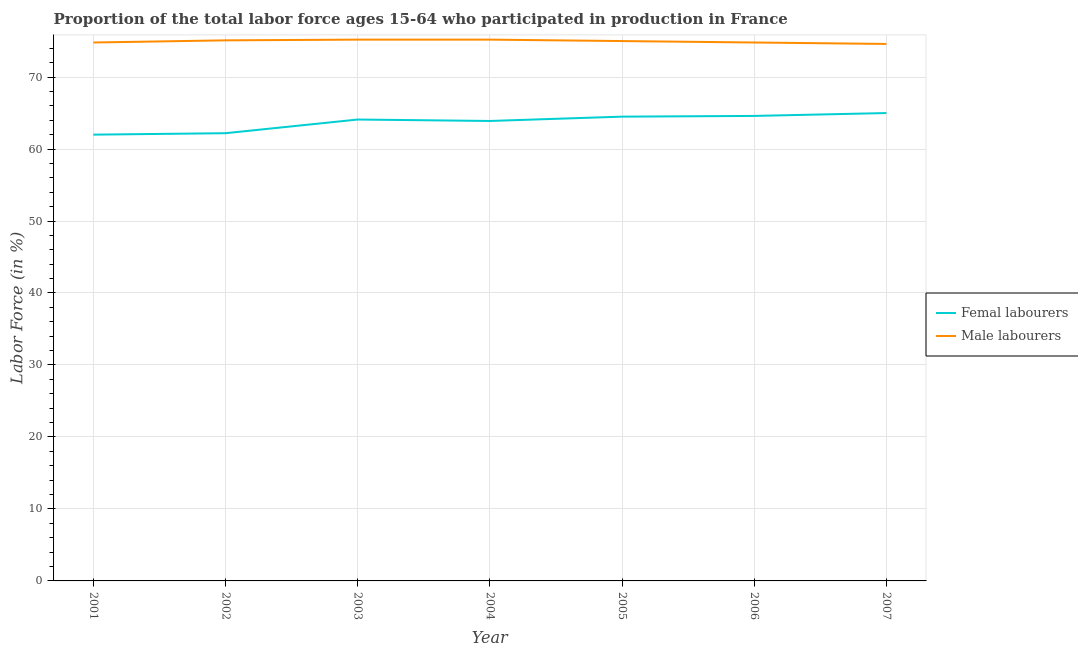Does the line corresponding to percentage of female labor force intersect with the line corresponding to percentage of male labour force?
Give a very brief answer. No. Is the number of lines equal to the number of legend labels?
Provide a short and direct response. Yes. What is the percentage of male labour force in 2006?
Keep it short and to the point. 74.8. Across all years, what is the maximum percentage of female labor force?
Provide a succinct answer. 65. Across all years, what is the minimum percentage of female labor force?
Offer a terse response. 62. In which year was the percentage of female labor force minimum?
Your response must be concise. 2001. What is the total percentage of male labour force in the graph?
Provide a succinct answer. 524.7. What is the difference between the percentage of male labour force in 2003 and that in 2005?
Offer a very short reply. 0.2. What is the difference between the percentage of male labour force in 2003 and the percentage of female labor force in 2001?
Give a very brief answer. 13.2. What is the average percentage of male labour force per year?
Offer a terse response. 74.96. In how many years, is the percentage of female labor force greater than 2 %?
Keep it short and to the point. 7. What is the ratio of the percentage of male labour force in 2001 to that in 2004?
Give a very brief answer. 0.99. Is the percentage of female labor force in 2004 less than that in 2005?
Give a very brief answer. Yes. Is the difference between the percentage of male labour force in 2004 and 2007 greater than the difference between the percentage of female labor force in 2004 and 2007?
Your response must be concise. Yes. What is the difference between the highest and the second highest percentage of male labour force?
Your answer should be very brief. 0. What is the difference between the highest and the lowest percentage of male labour force?
Offer a very short reply. 0.6. Is the sum of the percentage of male labour force in 2001 and 2007 greater than the maximum percentage of female labor force across all years?
Give a very brief answer. Yes. Is the percentage of female labor force strictly less than the percentage of male labour force over the years?
Give a very brief answer. Yes. How many lines are there?
Give a very brief answer. 2. Does the graph contain any zero values?
Make the answer very short. No. Where does the legend appear in the graph?
Your answer should be very brief. Center right. How many legend labels are there?
Ensure brevity in your answer.  2. What is the title of the graph?
Provide a short and direct response. Proportion of the total labor force ages 15-64 who participated in production in France. Does "Malaria" appear as one of the legend labels in the graph?
Provide a succinct answer. No. What is the label or title of the X-axis?
Give a very brief answer. Year. What is the Labor Force (in %) in Femal labourers in 2001?
Give a very brief answer. 62. What is the Labor Force (in %) in Male labourers in 2001?
Your answer should be compact. 74.8. What is the Labor Force (in %) in Femal labourers in 2002?
Make the answer very short. 62.2. What is the Labor Force (in %) in Male labourers in 2002?
Give a very brief answer. 75.1. What is the Labor Force (in %) of Femal labourers in 2003?
Keep it short and to the point. 64.1. What is the Labor Force (in %) in Male labourers in 2003?
Your answer should be compact. 75.2. What is the Labor Force (in %) in Femal labourers in 2004?
Keep it short and to the point. 63.9. What is the Labor Force (in %) in Male labourers in 2004?
Provide a succinct answer. 75.2. What is the Labor Force (in %) in Femal labourers in 2005?
Provide a short and direct response. 64.5. What is the Labor Force (in %) in Male labourers in 2005?
Give a very brief answer. 75. What is the Labor Force (in %) of Femal labourers in 2006?
Your answer should be very brief. 64.6. What is the Labor Force (in %) in Male labourers in 2006?
Provide a succinct answer. 74.8. What is the Labor Force (in %) of Femal labourers in 2007?
Your answer should be compact. 65. What is the Labor Force (in %) of Male labourers in 2007?
Provide a short and direct response. 74.6. Across all years, what is the maximum Labor Force (in %) of Male labourers?
Your response must be concise. 75.2. Across all years, what is the minimum Labor Force (in %) in Male labourers?
Offer a very short reply. 74.6. What is the total Labor Force (in %) in Femal labourers in the graph?
Ensure brevity in your answer.  446.3. What is the total Labor Force (in %) of Male labourers in the graph?
Provide a short and direct response. 524.7. What is the difference between the Labor Force (in %) of Femal labourers in 2001 and that in 2002?
Your answer should be very brief. -0.2. What is the difference between the Labor Force (in %) in Male labourers in 2001 and that in 2002?
Offer a terse response. -0.3. What is the difference between the Labor Force (in %) of Male labourers in 2001 and that in 2003?
Keep it short and to the point. -0.4. What is the difference between the Labor Force (in %) in Femal labourers in 2001 and that in 2004?
Offer a very short reply. -1.9. What is the difference between the Labor Force (in %) of Male labourers in 2001 and that in 2004?
Make the answer very short. -0.4. What is the difference between the Labor Force (in %) of Male labourers in 2001 and that in 2005?
Offer a very short reply. -0.2. What is the difference between the Labor Force (in %) of Femal labourers in 2001 and that in 2006?
Provide a succinct answer. -2.6. What is the difference between the Labor Force (in %) in Male labourers in 2001 and that in 2006?
Make the answer very short. 0. What is the difference between the Labor Force (in %) of Male labourers in 2002 and that in 2004?
Provide a short and direct response. -0.1. What is the difference between the Labor Force (in %) in Femal labourers in 2002 and that in 2005?
Your response must be concise. -2.3. What is the difference between the Labor Force (in %) in Male labourers in 2002 and that in 2005?
Provide a short and direct response. 0.1. What is the difference between the Labor Force (in %) of Femal labourers in 2002 and that in 2006?
Provide a short and direct response. -2.4. What is the difference between the Labor Force (in %) of Male labourers in 2002 and that in 2006?
Provide a succinct answer. 0.3. What is the difference between the Labor Force (in %) of Male labourers in 2002 and that in 2007?
Your answer should be compact. 0.5. What is the difference between the Labor Force (in %) of Femal labourers in 2003 and that in 2004?
Provide a succinct answer. 0.2. What is the difference between the Labor Force (in %) in Male labourers in 2003 and that in 2005?
Make the answer very short. 0.2. What is the difference between the Labor Force (in %) of Femal labourers in 2003 and that in 2006?
Offer a terse response. -0.5. What is the difference between the Labor Force (in %) in Male labourers in 2003 and that in 2006?
Make the answer very short. 0.4. What is the difference between the Labor Force (in %) in Femal labourers in 2004 and that in 2005?
Your answer should be very brief. -0.6. What is the difference between the Labor Force (in %) of Male labourers in 2004 and that in 2006?
Keep it short and to the point. 0.4. What is the difference between the Labor Force (in %) in Femal labourers in 2004 and that in 2007?
Offer a terse response. -1.1. What is the difference between the Labor Force (in %) of Male labourers in 2004 and that in 2007?
Provide a succinct answer. 0.6. What is the difference between the Labor Force (in %) in Male labourers in 2005 and that in 2006?
Provide a short and direct response. 0.2. What is the difference between the Labor Force (in %) of Femal labourers in 2005 and that in 2007?
Provide a short and direct response. -0.5. What is the difference between the Labor Force (in %) of Male labourers in 2005 and that in 2007?
Ensure brevity in your answer.  0.4. What is the difference between the Labor Force (in %) in Femal labourers in 2006 and that in 2007?
Your answer should be very brief. -0.4. What is the difference between the Labor Force (in %) in Male labourers in 2006 and that in 2007?
Offer a very short reply. 0.2. What is the difference between the Labor Force (in %) of Femal labourers in 2001 and the Labor Force (in %) of Male labourers in 2002?
Provide a succinct answer. -13.1. What is the difference between the Labor Force (in %) of Femal labourers in 2002 and the Labor Force (in %) of Male labourers in 2005?
Offer a very short reply. -12.8. What is the difference between the Labor Force (in %) of Femal labourers in 2002 and the Labor Force (in %) of Male labourers in 2007?
Your answer should be very brief. -12.4. What is the difference between the Labor Force (in %) of Femal labourers in 2003 and the Labor Force (in %) of Male labourers in 2004?
Ensure brevity in your answer.  -11.1. What is the difference between the Labor Force (in %) in Femal labourers in 2003 and the Labor Force (in %) in Male labourers in 2006?
Offer a very short reply. -10.7. What is the difference between the Labor Force (in %) of Femal labourers in 2004 and the Labor Force (in %) of Male labourers in 2006?
Give a very brief answer. -10.9. What is the difference between the Labor Force (in %) of Femal labourers in 2004 and the Labor Force (in %) of Male labourers in 2007?
Offer a very short reply. -10.7. What is the difference between the Labor Force (in %) in Femal labourers in 2005 and the Labor Force (in %) in Male labourers in 2007?
Your response must be concise. -10.1. What is the difference between the Labor Force (in %) of Femal labourers in 2006 and the Labor Force (in %) of Male labourers in 2007?
Your answer should be compact. -10. What is the average Labor Force (in %) in Femal labourers per year?
Provide a succinct answer. 63.76. What is the average Labor Force (in %) of Male labourers per year?
Ensure brevity in your answer.  74.96. In the year 2001, what is the difference between the Labor Force (in %) of Femal labourers and Labor Force (in %) of Male labourers?
Offer a terse response. -12.8. In the year 2003, what is the difference between the Labor Force (in %) in Femal labourers and Labor Force (in %) in Male labourers?
Provide a short and direct response. -11.1. In the year 2005, what is the difference between the Labor Force (in %) in Femal labourers and Labor Force (in %) in Male labourers?
Your answer should be very brief. -10.5. In the year 2007, what is the difference between the Labor Force (in %) of Femal labourers and Labor Force (in %) of Male labourers?
Your answer should be compact. -9.6. What is the ratio of the Labor Force (in %) of Male labourers in 2001 to that in 2002?
Provide a succinct answer. 1. What is the ratio of the Labor Force (in %) of Femal labourers in 2001 to that in 2003?
Keep it short and to the point. 0.97. What is the ratio of the Labor Force (in %) of Male labourers in 2001 to that in 2003?
Give a very brief answer. 0.99. What is the ratio of the Labor Force (in %) in Femal labourers in 2001 to that in 2004?
Ensure brevity in your answer.  0.97. What is the ratio of the Labor Force (in %) of Male labourers in 2001 to that in 2004?
Keep it short and to the point. 0.99. What is the ratio of the Labor Force (in %) in Femal labourers in 2001 to that in 2005?
Keep it short and to the point. 0.96. What is the ratio of the Labor Force (in %) in Male labourers in 2001 to that in 2005?
Provide a short and direct response. 1. What is the ratio of the Labor Force (in %) of Femal labourers in 2001 to that in 2006?
Ensure brevity in your answer.  0.96. What is the ratio of the Labor Force (in %) in Male labourers in 2001 to that in 2006?
Give a very brief answer. 1. What is the ratio of the Labor Force (in %) of Femal labourers in 2001 to that in 2007?
Provide a succinct answer. 0.95. What is the ratio of the Labor Force (in %) in Male labourers in 2001 to that in 2007?
Make the answer very short. 1. What is the ratio of the Labor Force (in %) of Femal labourers in 2002 to that in 2003?
Keep it short and to the point. 0.97. What is the ratio of the Labor Force (in %) of Male labourers in 2002 to that in 2003?
Offer a terse response. 1. What is the ratio of the Labor Force (in %) in Femal labourers in 2002 to that in 2004?
Your answer should be very brief. 0.97. What is the ratio of the Labor Force (in %) in Male labourers in 2002 to that in 2005?
Give a very brief answer. 1. What is the ratio of the Labor Force (in %) in Femal labourers in 2002 to that in 2006?
Offer a very short reply. 0.96. What is the ratio of the Labor Force (in %) of Male labourers in 2002 to that in 2006?
Your answer should be very brief. 1. What is the ratio of the Labor Force (in %) of Femal labourers in 2002 to that in 2007?
Offer a terse response. 0.96. What is the ratio of the Labor Force (in %) of Male labourers in 2002 to that in 2007?
Your answer should be compact. 1.01. What is the ratio of the Labor Force (in %) in Femal labourers in 2003 to that in 2004?
Keep it short and to the point. 1. What is the ratio of the Labor Force (in %) of Male labourers in 2003 to that in 2004?
Your answer should be very brief. 1. What is the ratio of the Labor Force (in %) in Male labourers in 2003 to that in 2006?
Give a very brief answer. 1.01. What is the ratio of the Labor Force (in %) in Femal labourers in 2003 to that in 2007?
Your response must be concise. 0.99. What is the ratio of the Labor Force (in %) of Male labourers in 2003 to that in 2007?
Your answer should be very brief. 1.01. What is the ratio of the Labor Force (in %) of Male labourers in 2004 to that in 2006?
Offer a very short reply. 1.01. What is the ratio of the Labor Force (in %) of Femal labourers in 2004 to that in 2007?
Your response must be concise. 0.98. What is the ratio of the Labor Force (in %) of Male labourers in 2004 to that in 2007?
Ensure brevity in your answer.  1.01. What is the ratio of the Labor Force (in %) of Male labourers in 2005 to that in 2006?
Provide a short and direct response. 1. What is the ratio of the Labor Force (in %) in Male labourers in 2005 to that in 2007?
Give a very brief answer. 1.01. What is the difference between the highest and the lowest Labor Force (in %) in Femal labourers?
Offer a very short reply. 3. 